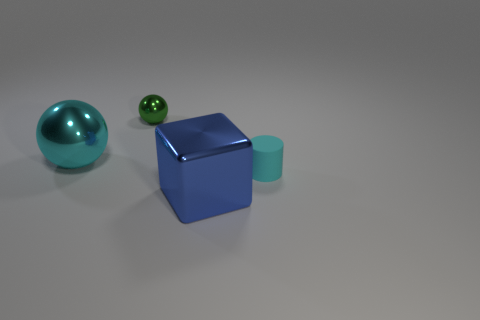There is a small object behind the tiny cyan cylinder; is there a cyan shiny thing to the left of it?
Ensure brevity in your answer.  Yes. What number of other big objects have the same material as the green object?
Make the answer very short. 2. What is the size of the metallic object that is in front of the big metal thing left of the large block that is to the left of the tiny cyan rubber cylinder?
Offer a very short reply. Large. There is a small cyan object; how many small green metal things are on the left side of it?
Make the answer very short. 1. Is the number of big purple matte spheres greater than the number of tiny cyan matte things?
Provide a succinct answer. No. What size is the ball that is the same color as the tiny rubber object?
Offer a very short reply. Large. What size is the shiny object that is in front of the green metallic ball and behind the blue cube?
Keep it short and to the point. Large. What is the cyan object right of the tiny green object that is left of the large object that is in front of the cyan rubber cylinder made of?
Provide a short and direct response. Rubber. There is a cylinder that is the same color as the big sphere; what is its material?
Provide a succinct answer. Rubber. Do the object that is on the right side of the large blue shiny object and the large cube on the left side of the cyan rubber object have the same color?
Offer a terse response. No. 